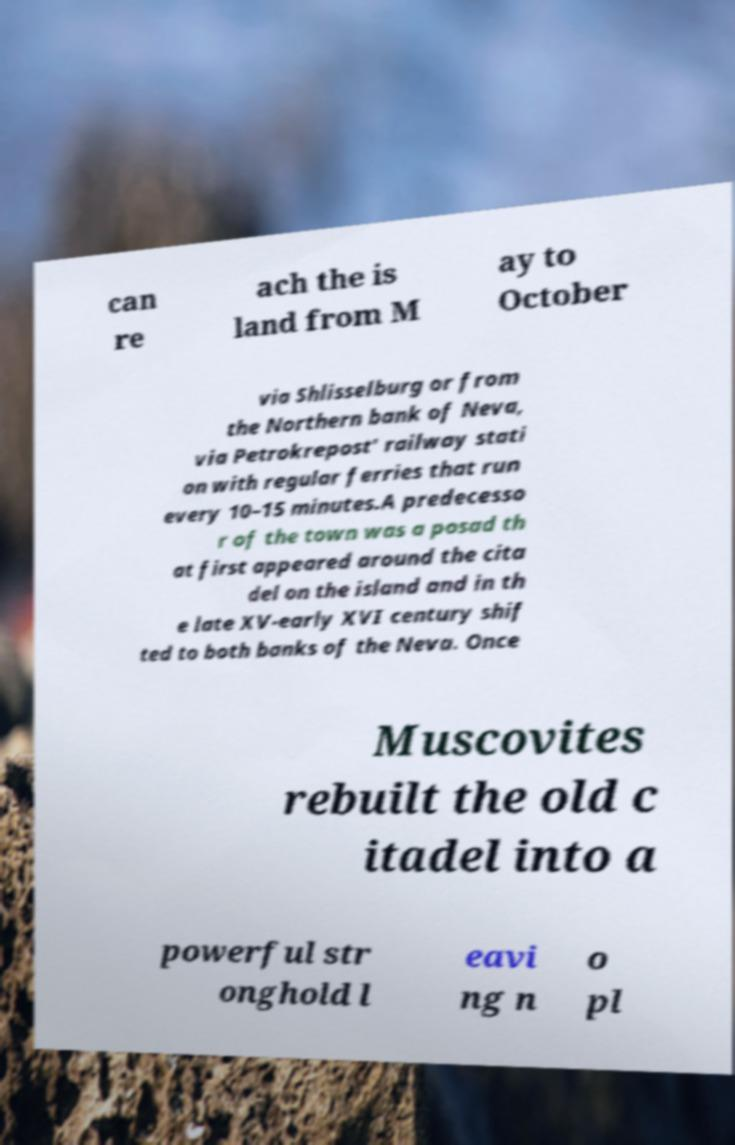For documentation purposes, I need the text within this image transcribed. Could you provide that? can re ach the is land from M ay to October via Shlisselburg or from the Northern bank of Neva, via Petrokrepost' railway stati on with regular ferries that run every 10–15 minutes.A predecesso r of the town was a posad th at first appeared around the cita del on the island and in th e late XV-early XVI century shif ted to both banks of the Neva. Once Muscovites rebuilt the old c itadel into a powerful str onghold l eavi ng n o pl 